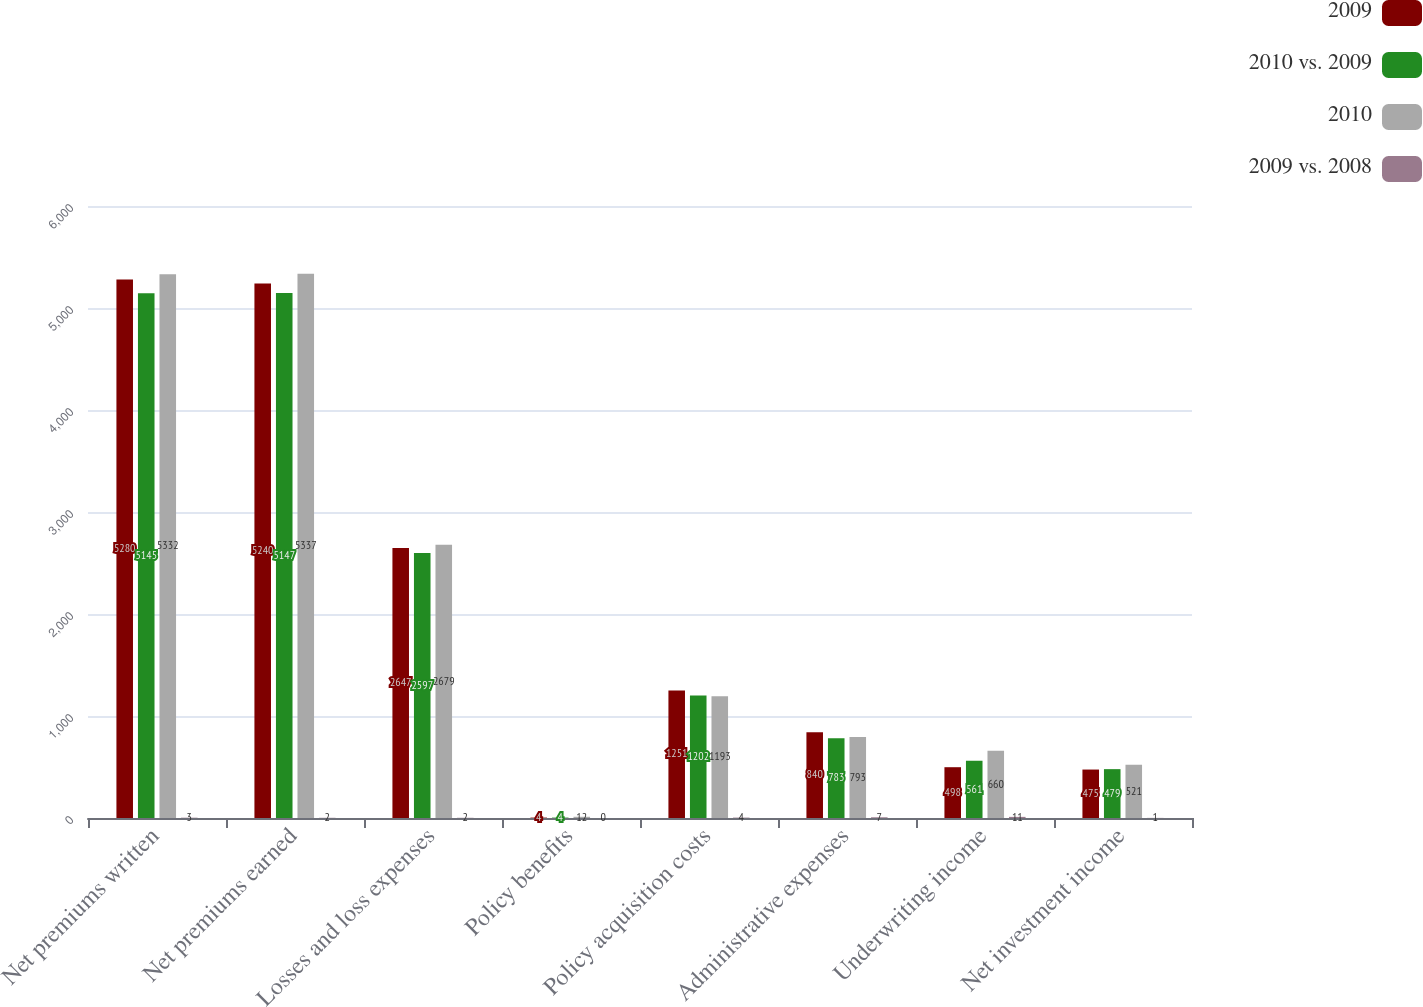Convert chart to OTSL. <chart><loc_0><loc_0><loc_500><loc_500><stacked_bar_chart><ecel><fcel>Net premiums written<fcel>Net premiums earned<fcel>Losses and loss expenses<fcel>Policy benefits<fcel>Policy acquisition costs<fcel>Administrative expenses<fcel>Underwriting income<fcel>Net investment income<nl><fcel>2009<fcel>5280<fcel>5240<fcel>2647<fcel>4<fcel>1251<fcel>840<fcel>498<fcel>475<nl><fcel>2010 vs. 2009<fcel>5145<fcel>5147<fcel>2597<fcel>4<fcel>1202<fcel>783<fcel>561<fcel>479<nl><fcel>2010<fcel>5332<fcel>5337<fcel>2679<fcel>12<fcel>1193<fcel>793<fcel>660<fcel>521<nl><fcel>2009 vs. 2008<fcel>3<fcel>2<fcel>2<fcel>0<fcel>4<fcel>7<fcel>11<fcel>1<nl></chart> 